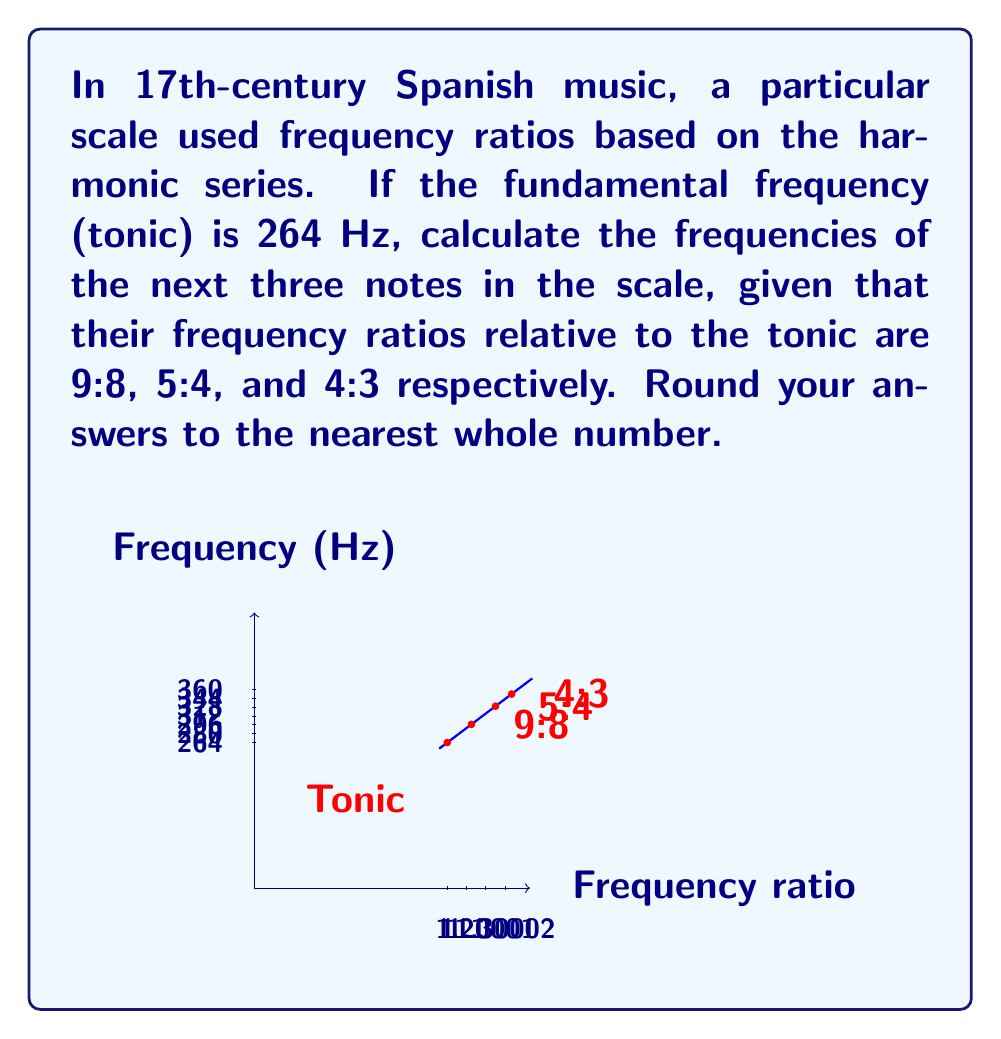Help me with this question. To solve this problem, we need to apply the given frequency ratios to the fundamental frequency. Let's go through this step-by-step:

1) The fundamental frequency (tonic) is given as 264 Hz.

2) For the second note (9:8 ratio):
   $$f_2 = 264 \times \frac{9}{8} = 297 \text{ Hz}$$

3) For the third note (5:4 ratio):
   $$f_3 = 264 \times \frac{5}{4} = 330 \text{ Hz}$$

4) For the fourth note (4:3 ratio):
   $$f_4 = 264 \times \frac{4}{3} = 352 \text{ Hz}$$

5) Rounding to the nearest whole number:
   - Second note: 297 Hz (already a whole number)
   - Third note: 330 Hz (already a whole number)
   - Fourth note: 352 Hz (already a whole number)

These frequency ratios are based on the harmonic series, which was a common foundation for musical scales in 17th-century Spanish music. The ratios 9:8, 5:4, and 4:3 correspond to the major second, major third, and perfect fourth intervals respectively in just intonation.
Answer: 297 Hz, 330 Hz, 352 Hz 